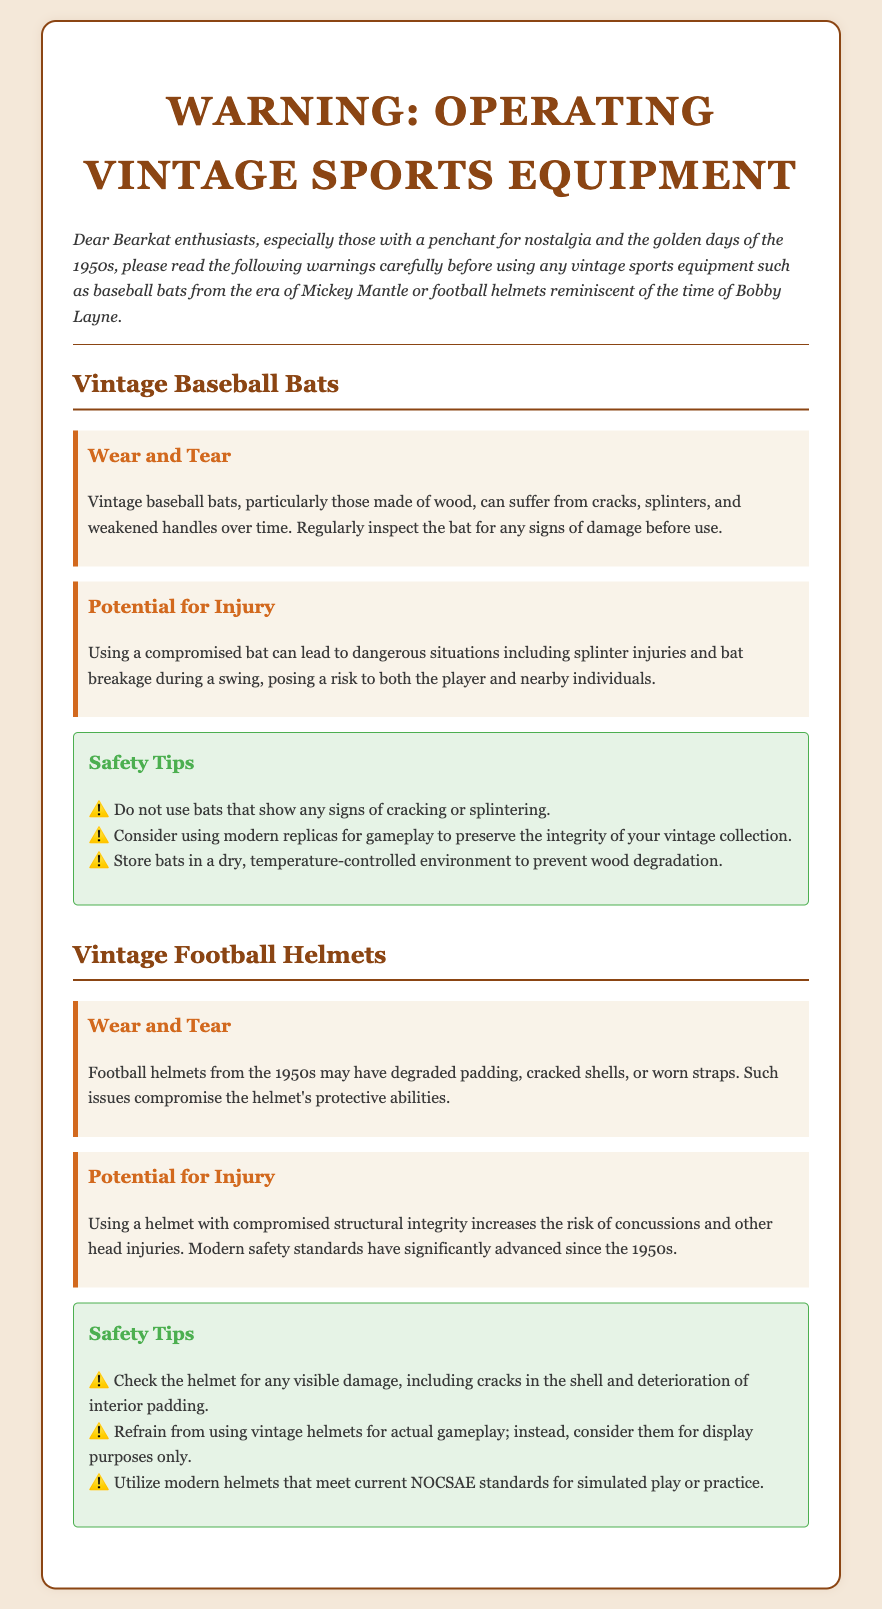What is the main focus of the document? The document emphasizes warnings about using vintage sports equipment, particularly baseball bats and football helmets.
Answer: Vintage sports equipment What year does the vintage equipment reference? The document specifies equipment from the era of the 1950s.
Answer: 1950s What should be checked on vintage baseball bats? The document advises checking for signs of cracking or splintering before use.
Answer: Cracking or splintering What type of injury can occur from a compromised football helmet? The document notes that using a compromised helmet increases the risk of concussions.
Answer: Concussions What is one of the safety tips for vintage baseball bats? The document suggests not using bats that show any signs of damage.
Answer: Do not use damaged bats What should vintage football helmets be used for, according to the document? The document recommends using them for display purposes only.
Answer: Display purposes only What materials indicate wear and tear for vintage baseball bats? The document mentions that wooden bats can suffer from cracks and splinters over time.
Answer: Wood, cracks, splinters What modern standards should helmets meet for simulated play? The document states that modern helmets should meet NOCSAE standards.
Answer: NOCSAE standards 